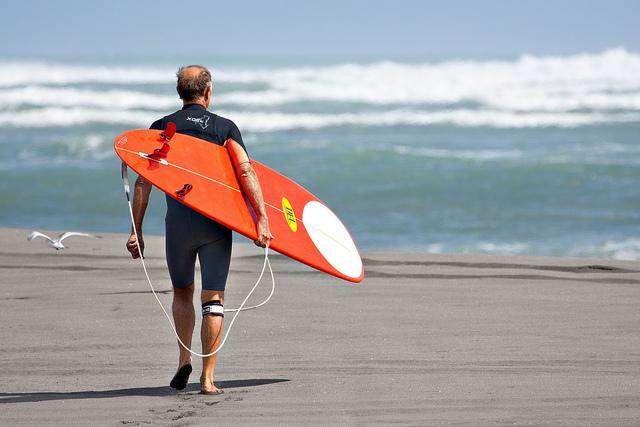What is the cable on the man's leg called?

Choices:
A) locker
B) surfboard leash
C) straps
D) usb cable surfboard leash 